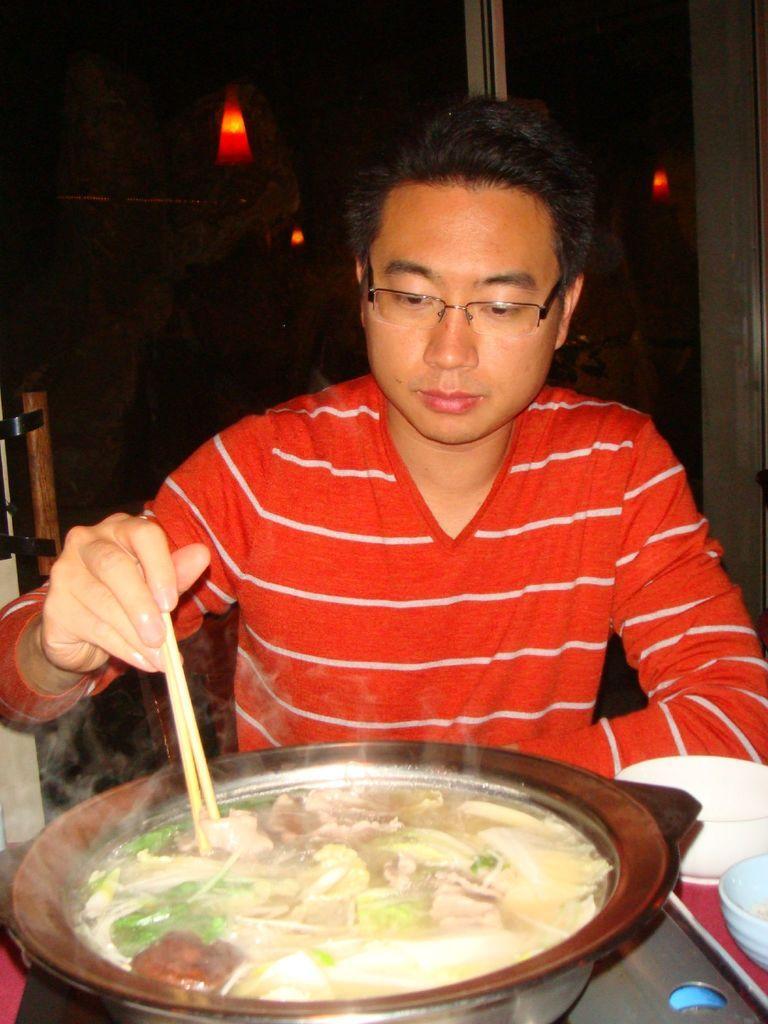In one or two sentences, can you explain what this image depicts? In this image I can see a man wearing specs and red t shirt. I can see h e is holding chopstick in his right hand. Here I can see food in a bowl. 